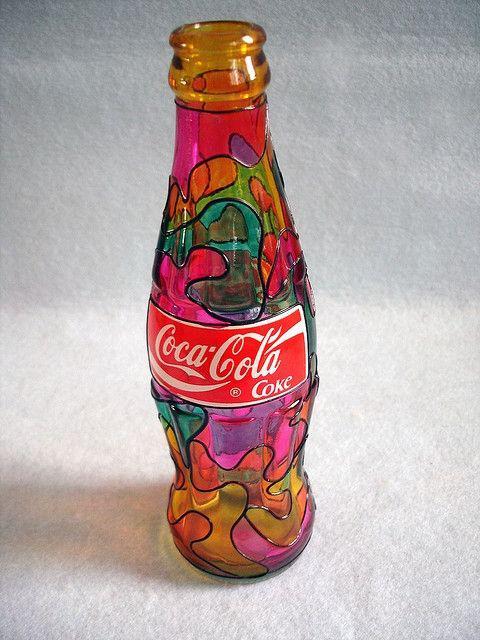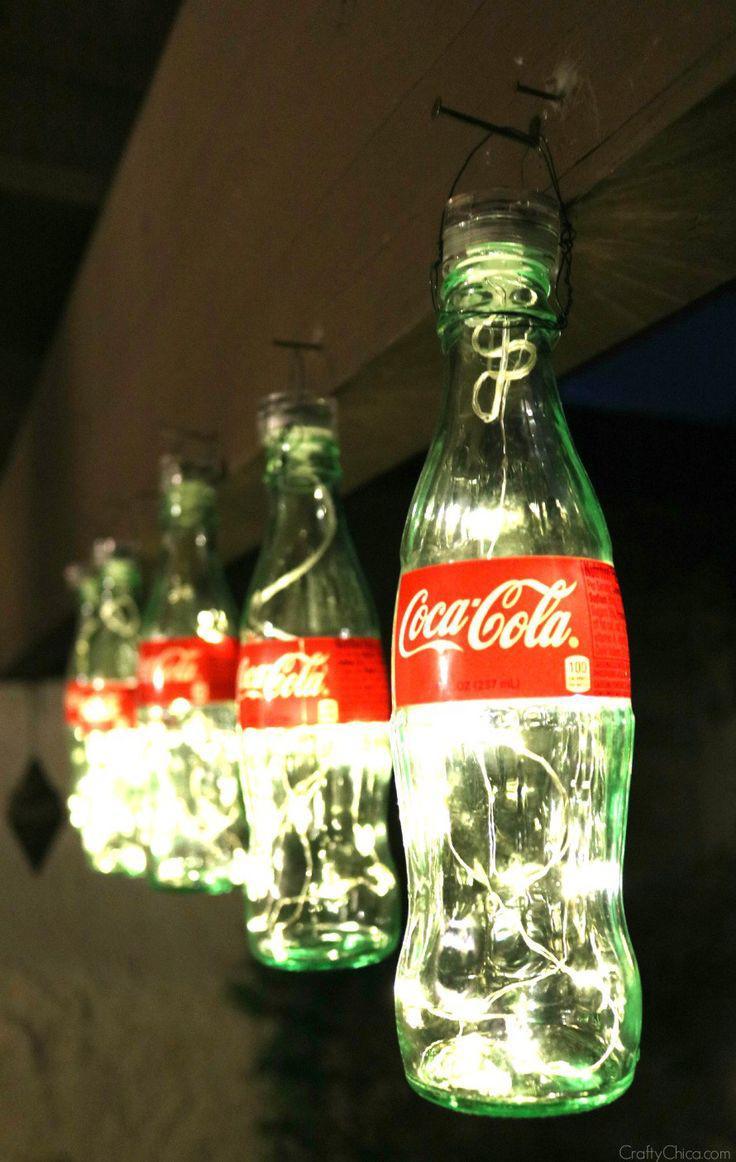The first image is the image on the left, the second image is the image on the right. Assess this claim about the two images: "There are exactly two bottles.". Correct or not? Answer yes or no. No. The first image is the image on the left, the second image is the image on the right. Analyze the images presented: Is the assertion "One image contains several evenly spaced glass soda bottles with white lettering on red labels." valid? Answer yes or no. Yes. 